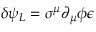Convert formula to latex. <formula><loc_0><loc_0><loc_500><loc_500>\delta \psi _ { L } = \sigma ^ { \mu } \partial _ { \mu } \phi \epsilon</formula> 